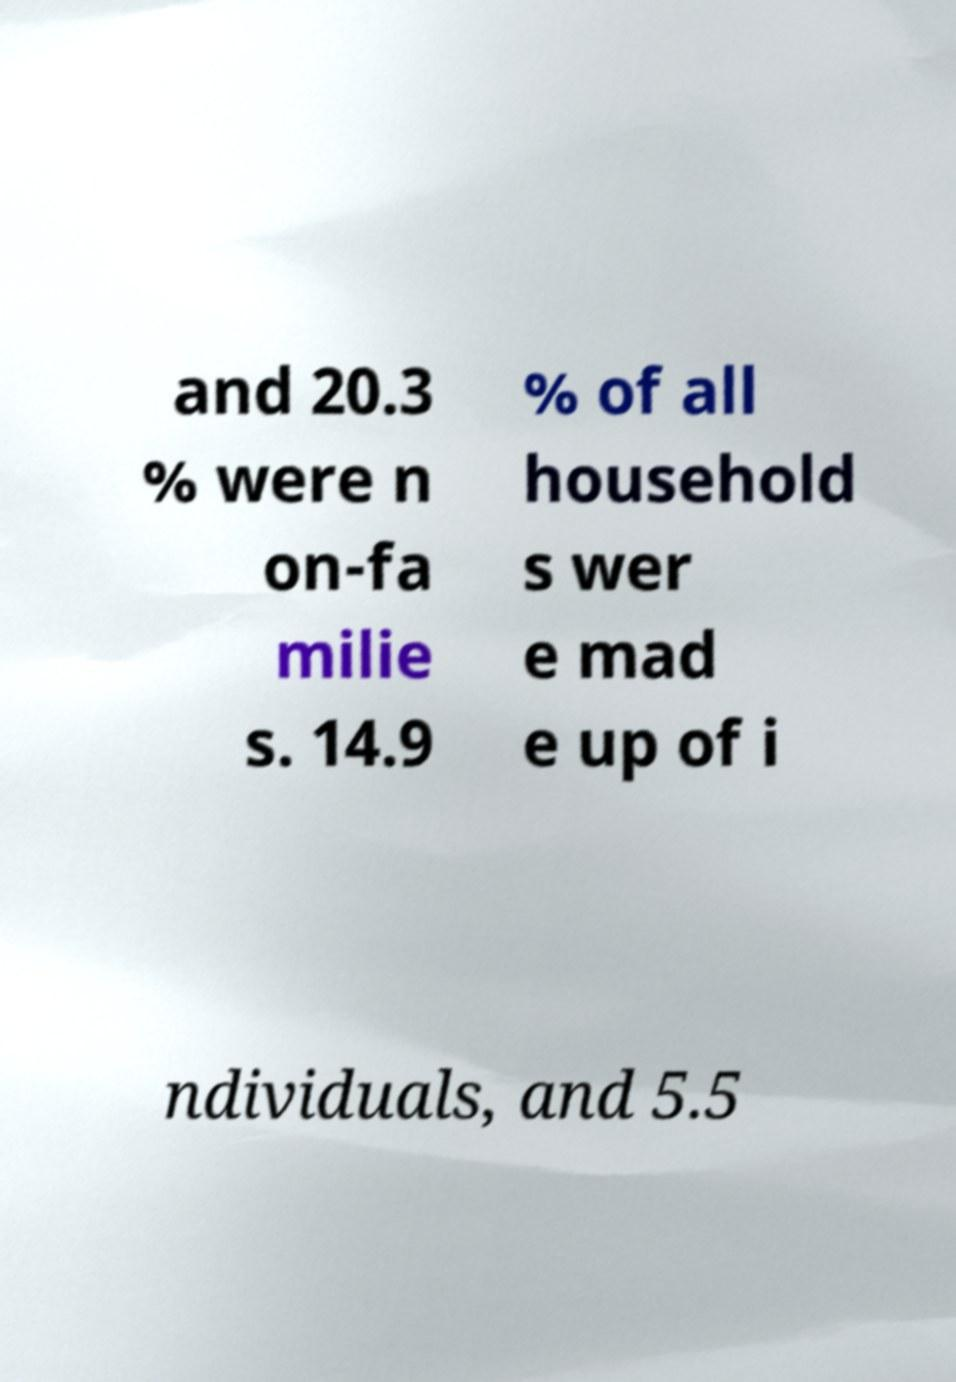Please identify and transcribe the text found in this image. and 20.3 % were n on-fa milie s. 14.9 % of all household s wer e mad e up of i ndividuals, and 5.5 